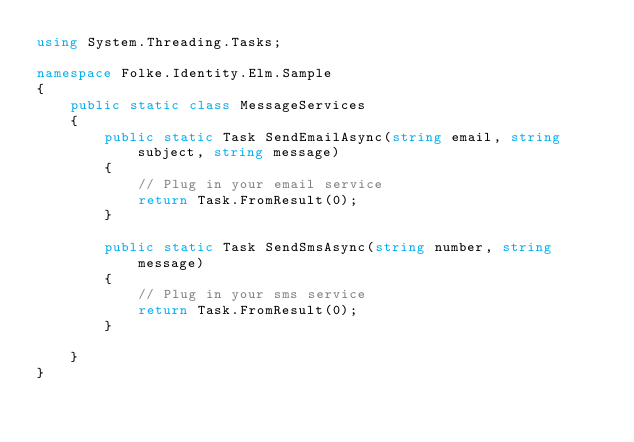Convert code to text. <code><loc_0><loc_0><loc_500><loc_500><_C#_>using System.Threading.Tasks;

namespace Folke.Identity.Elm.Sample
{
    public static class MessageServices
    {
        public static Task SendEmailAsync(string email, string subject, string message)
        {
            // Plug in your email service
            return Task.FromResult(0);
        }

        public static Task SendSmsAsync(string number, string message)
        {
            // Plug in your sms service
            return Task.FromResult(0);
        }

    }
}</code> 